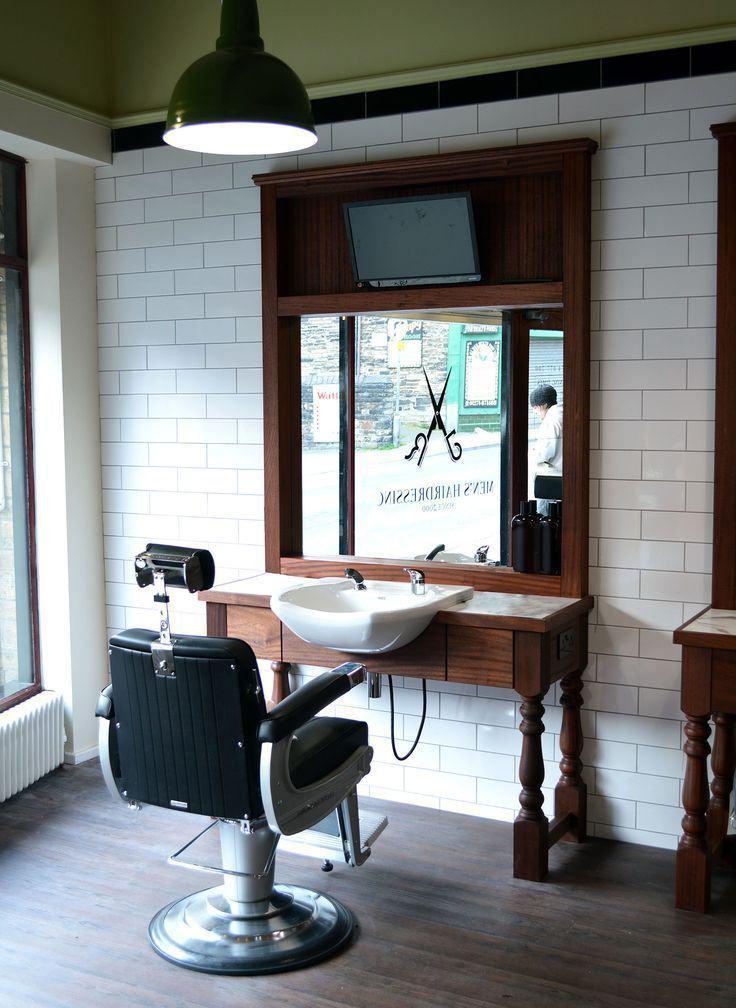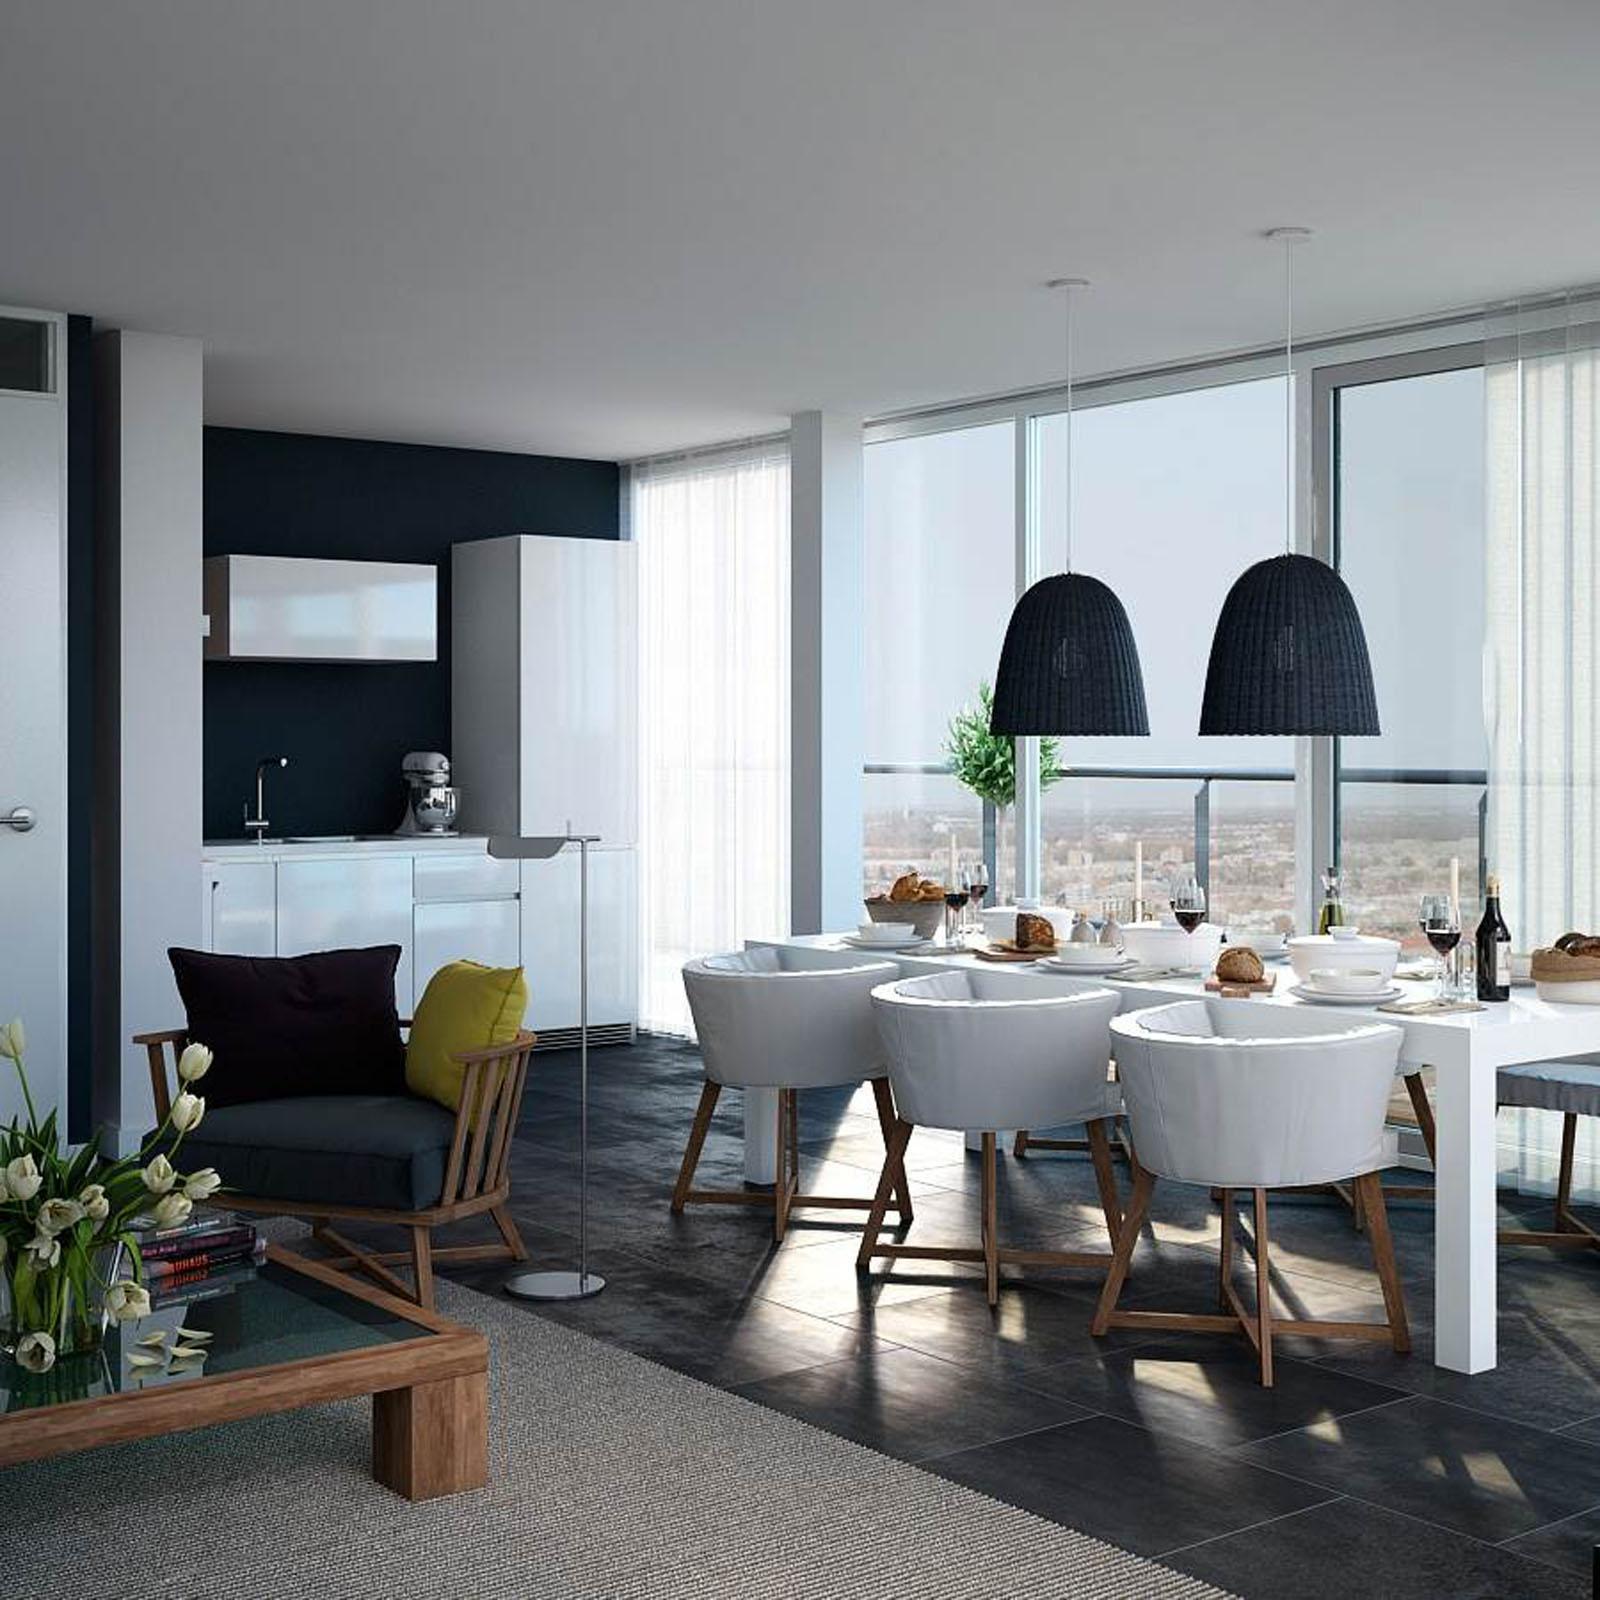The first image is the image on the left, the second image is the image on the right. For the images shown, is this caption "The left and right image contains the same number chairs." true? Answer yes or no. No. The first image is the image on the left, the second image is the image on the right. Given the left and right images, does the statement "The left image features at least one empty back-turned black barber chair in front of a rectangular mirror." hold true? Answer yes or no. Yes. 